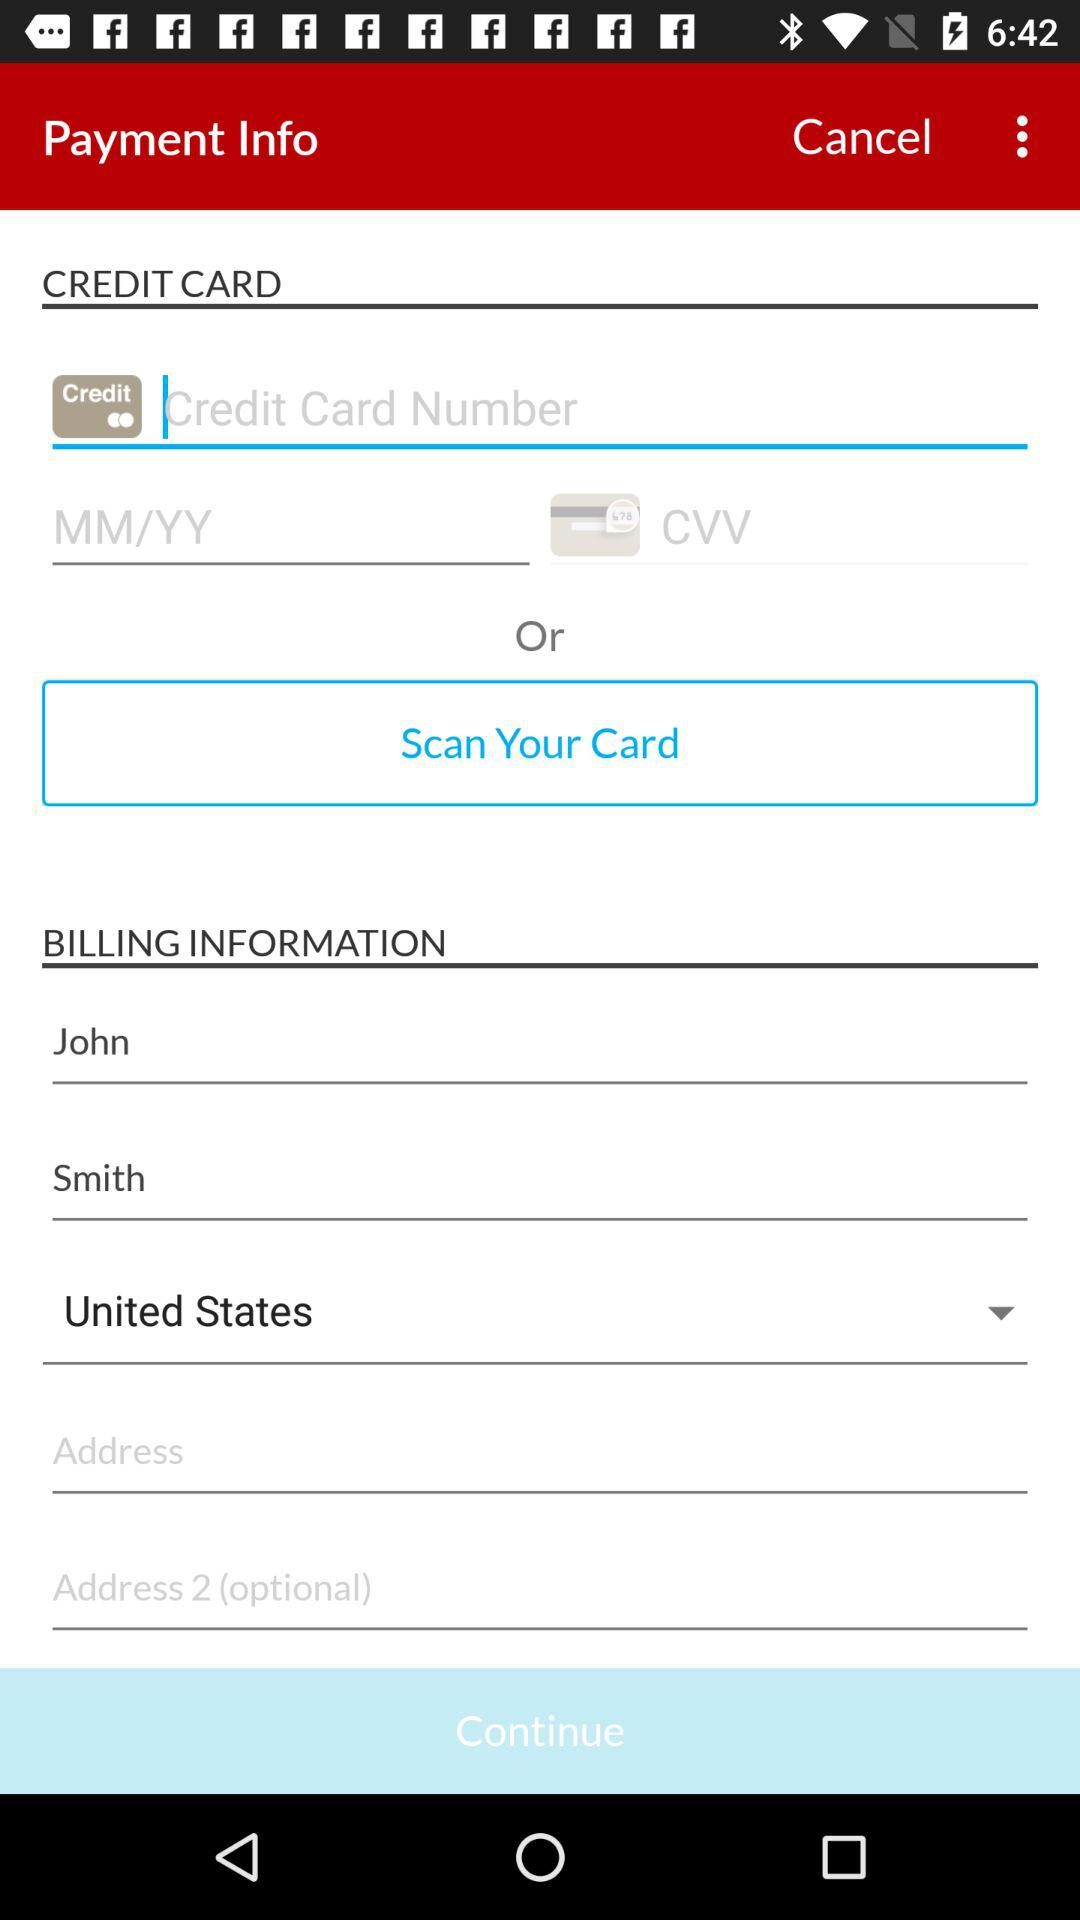What is the last name of the user? The last name of the user is Smith. 